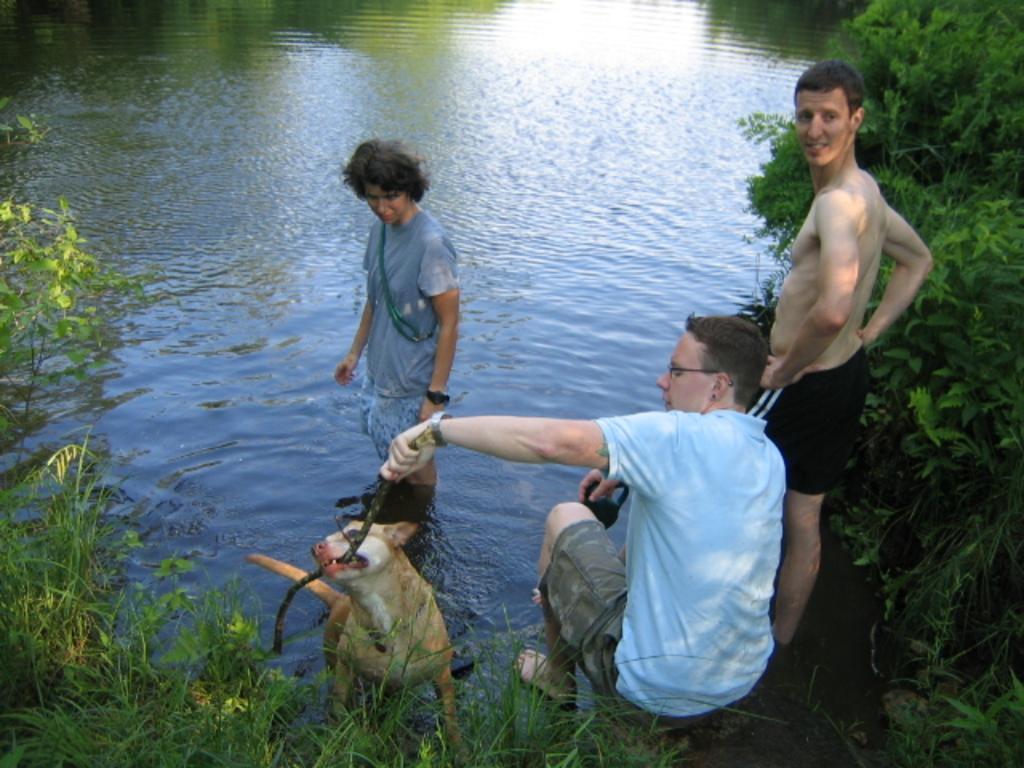Describe this image in one or two sentences. In this picture we can see three men and a dog where one is standing in a water where other is holding stick in hand and in the background we can see water, trees. 